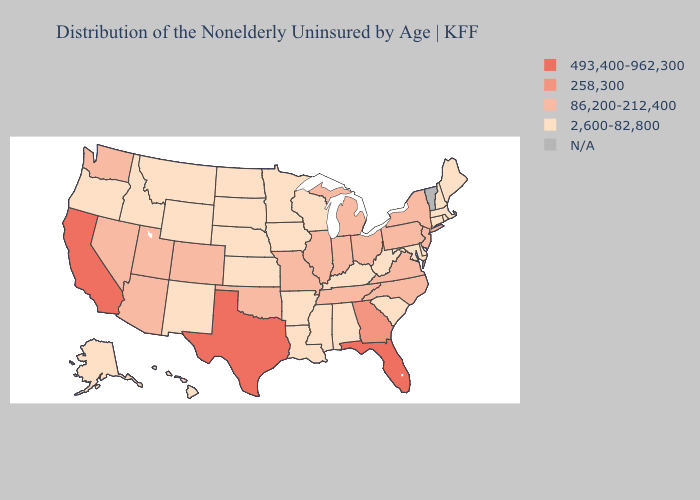What is the lowest value in states that border Mississippi?
Answer briefly. 2,600-82,800. Does New York have the lowest value in the USA?
Be succinct. No. What is the highest value in the MidWest ?
Answer briefly. 86,200-212,400. Which states hav the highest value in the MidWest?
Be succinct. Illinois, Indiana, Michigan, Missouri, Ohio. Which states have the highest value in the USA?
Concise answer only. California, Florida, Texas. Name the states that have a value in the range 493,400-962,300?
Quick response, please. California, Florida, Texas. What is the value of Missouri?
Keep it brief. 86,200-212,400. What is the value of Colorado?
Write a very short answer. 86,200-212,400. Which states have the highest value in the USA?
Write a very short answer. California, Florida, Texas. What is the lowest value in the South?
Quick response, please. 2,600-82,800. Name the states that have a value in the range 258,300?
Short answer required. Georgia. How many symbols are there in the legend?
Keep it brief. 5. 